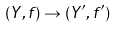Convert formula to latex. <formula><loc_0><loc_0><loc_500><loc_500>( Y , f ) \rightarrow ( Y ^ { \prime } , f ^ { \prime } )</formula> 